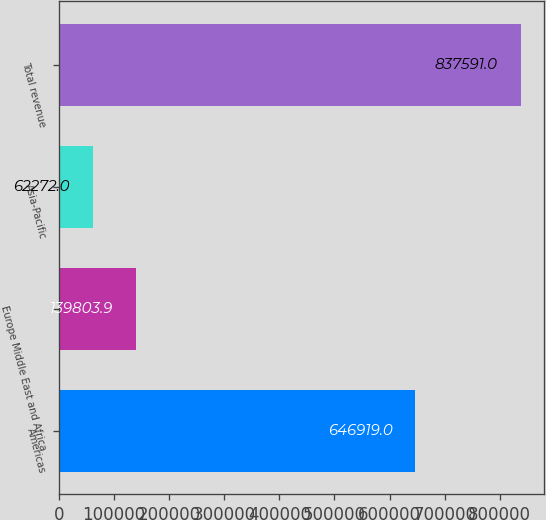Convert chart to OTSL. <chart><loc_0><loc_0><loc_500><loc_500><bar_chart><fcel>Americas<fcel>Europe Middle East and Africa<fcel>Asia-Pacific<fcel>Total revenue<nl><fcel>646919<fcel>139804<fcel>62272<fcel>837591<nl></chart> 